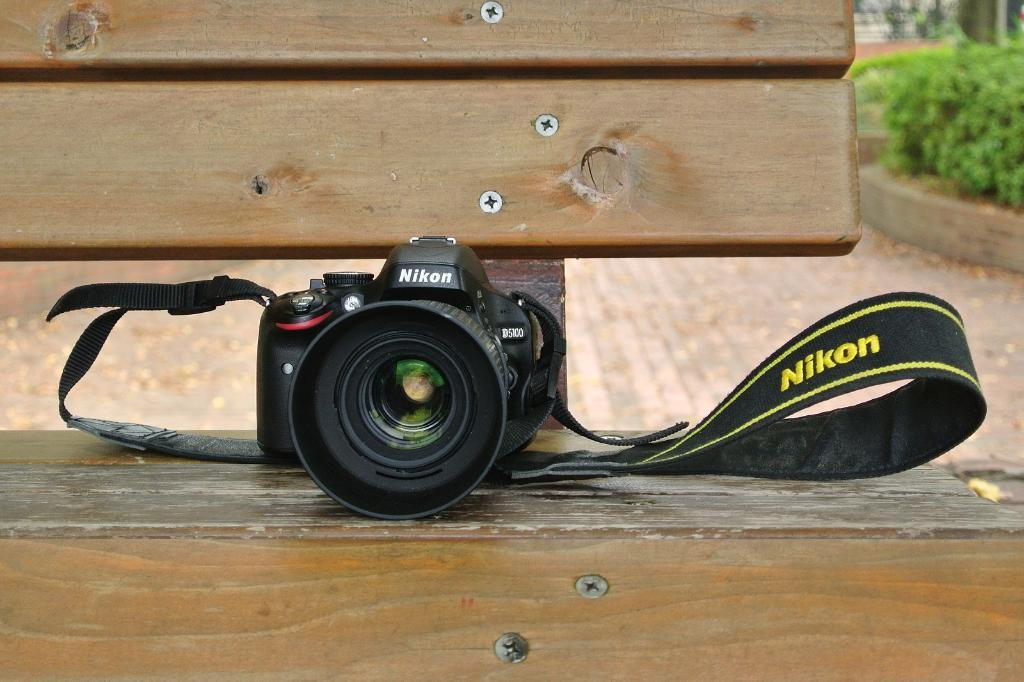What type of camera is visible in the image? There is a Nikon camera in the image. Where is the camera placed? The camera is placed on a bench. Can you describe the material of the bench? The bench is made of wood. What can be seen at the bottom of the image? There is a road at the bottom of the image. What type of vegetation is visible in the background? There are plants in the background of the image. What type of grain is visible on the bench in the image? There is no text or grain visible on the bench in the image; it is made of wood. 